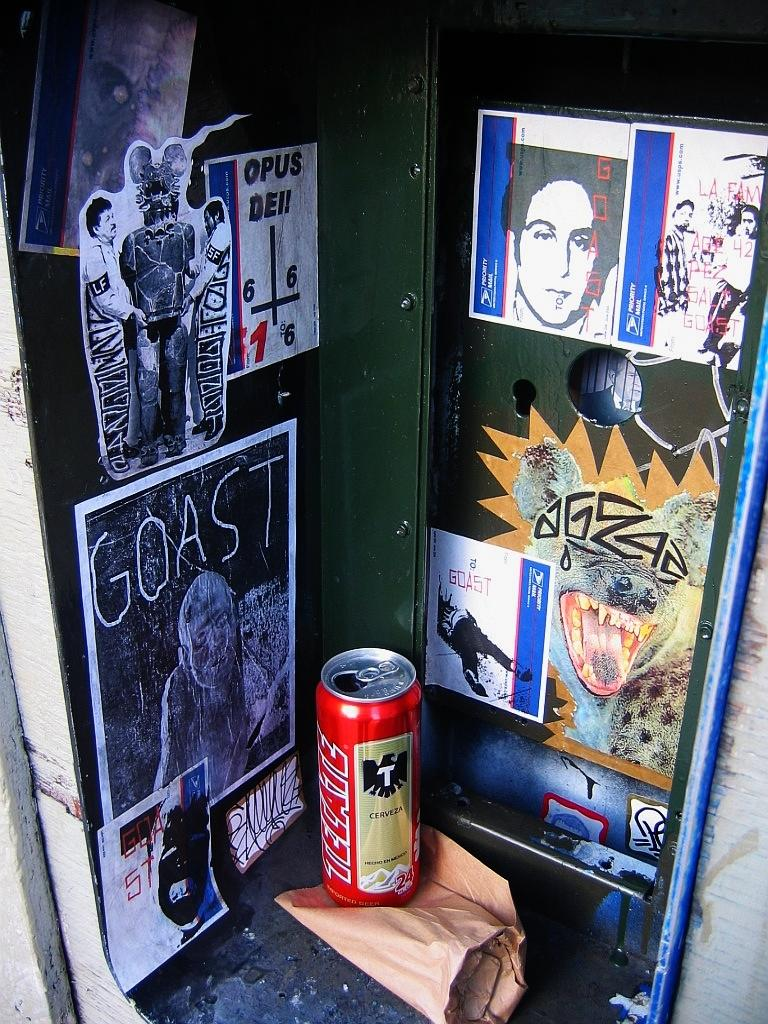<image>
Give a short and clear explanation of the subsequent image. the word goast is on a drawing next to the can 